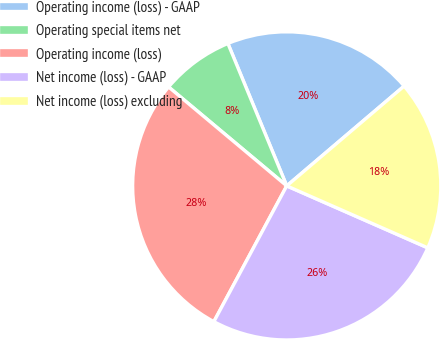<chart> <loc_0><loc_0><loc_500><loc_500><pie_chart><fcel>Operating income (loss) - GAAP<fcel>Operating special items net<fcel>Operating income (loss)<fcel>Net income (loss) - GAAP<fcel>Net income (loss) excluding<nl><fcel>20.02%<fcel>7.67%<fcel>28.25%<fcel>26.25%<fcel>17.8%<nl></chart> 